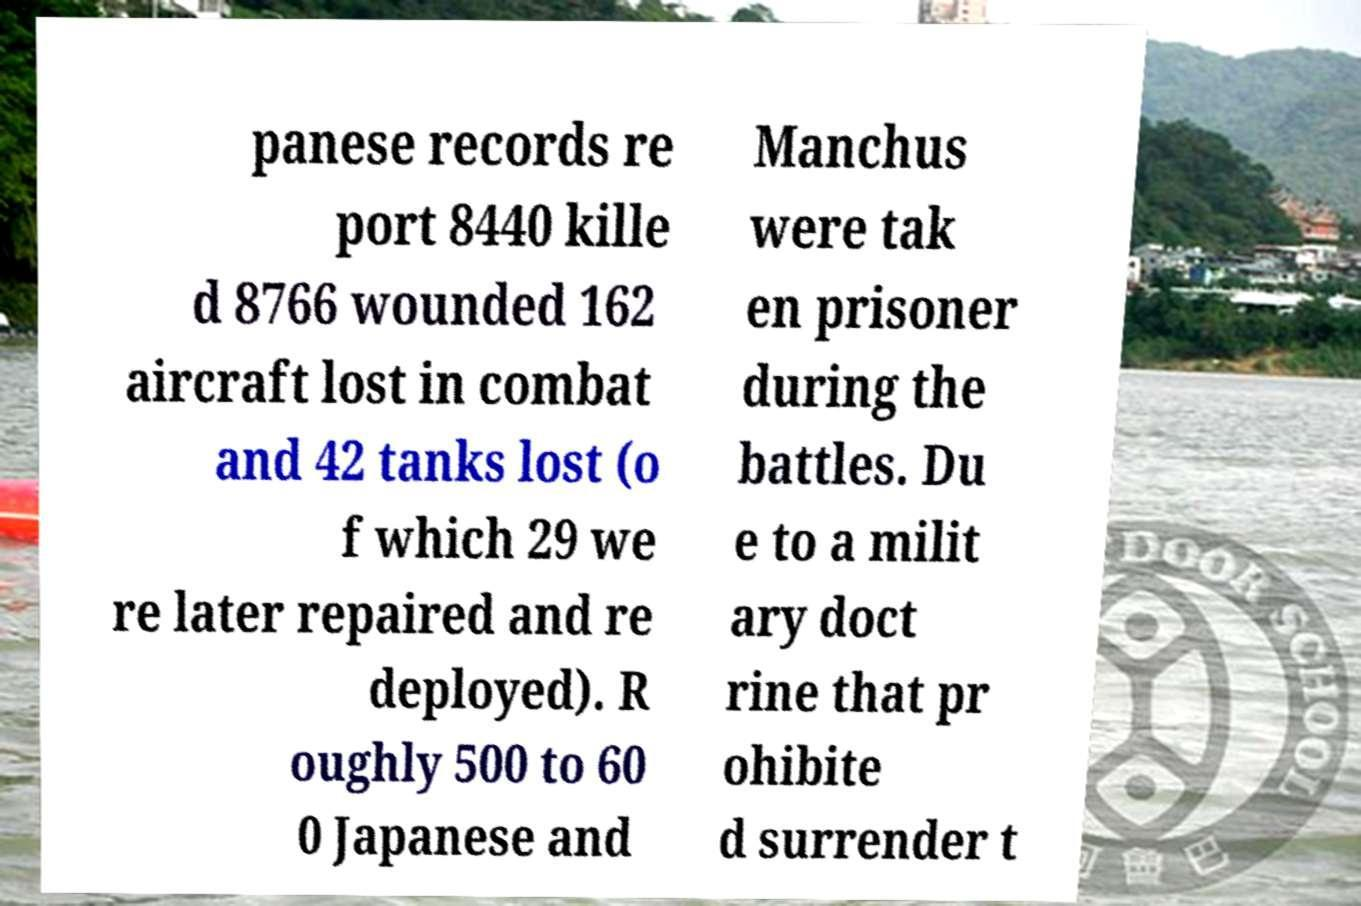Please read and relay the text visible in this image. What does it say? panese records re port 8440 kille d 8766 wounded 162 aircraft lost in combat and 42 tanks lost (o f which 29 we re later repaired and re deployed). R oughly 500 to 60 0 Japanese and Manchus were tak en prisoner during the battles. Du e to a milit ary doct rine that pr ohibite d surrender t 